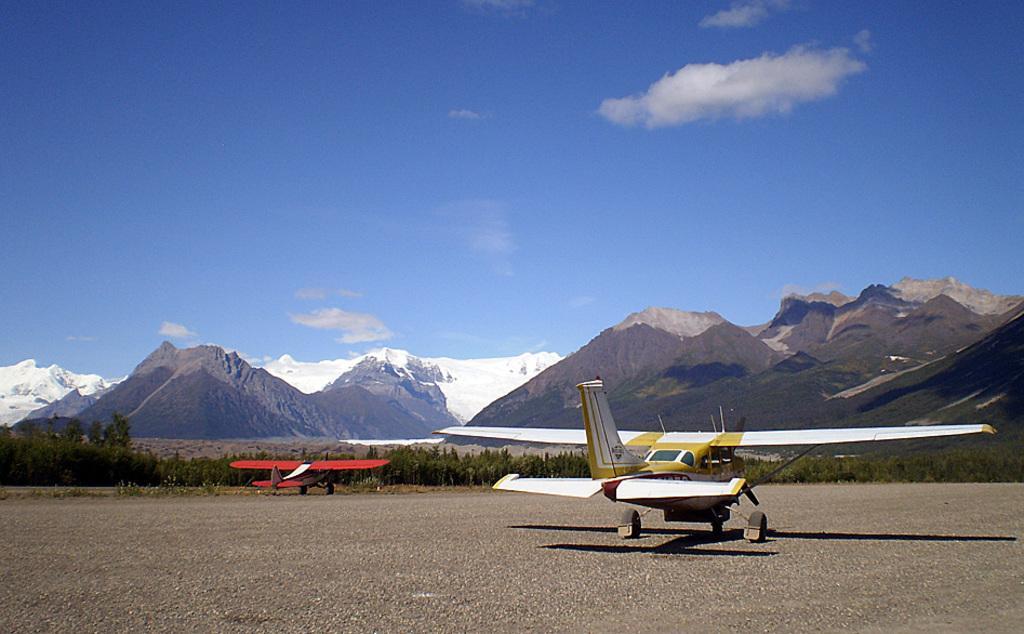Can you describe this image briefly? In the image we can see there are two aircrafts parked on the road. Behind there are lot of trees and there are mountains. There is a cloudy sky. 